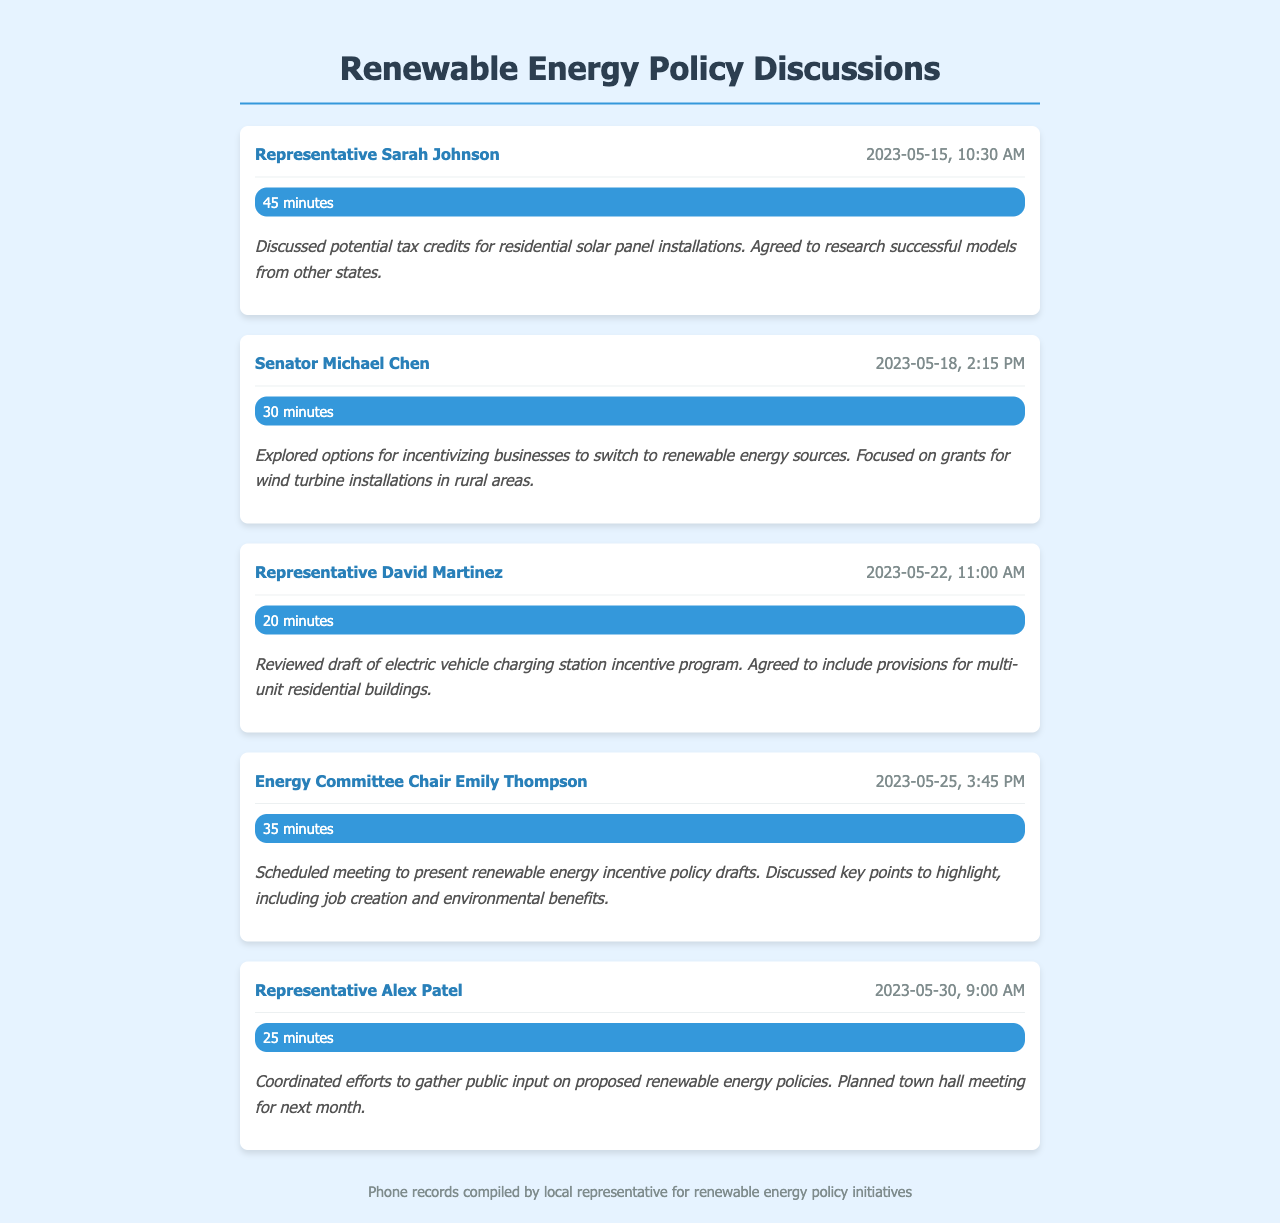What is the date of the call with Representative Sarah Johnson? The date of the call with Representative Sarah Johnson is mentioned in the record as 2023-05-15.
Answer: 2023-05-15 How long was the call with Senator Michael Chen? The duration of the call with Senator Michael Chen is noted as 30 minutes.
Answer: 30 minutes What specific solar incentive was discussed with Representative Sarah Johnson? The conversation with Representative Sarah Johnson covered potential tax credits for residential solar panel installations.
Answer: tax credits Who was responsible for coordinating public input on the renewable energy policies? The record indicates that Representative Alex Patel coordinated efforts to gather public input.
Answer: Representative Alex Patel What key points were to be highlighted in the scheduled meeting with Energy Committee Chair Emily Thompson? The key points discussed include job creation and environmental benefits.
Answer: job creation and environmental benefits What was the focus of the discussion with Representative David Martinez? The topic with Representative David Martinez was about a draft for an electric vehicle charging station incentive program.
Answer: electric vehicle charging station incentive program When is the planned town hall meeting for public input? The specific date of the town hall meeting is not provided but is mentioned as being scheduled for next month.
Answer: next month What type of incentives were explored with Senator Michael Chen? The call with Senator Michael Chen focused on grants for wind turbine installations.
Answer: grants for wind turbine installations What was the main purpose of the calls included in the document? The main purpose of the calls was to discuss drafting new renewable energy incentive policies.
Answer: drafting new renewable energy incentive policies 